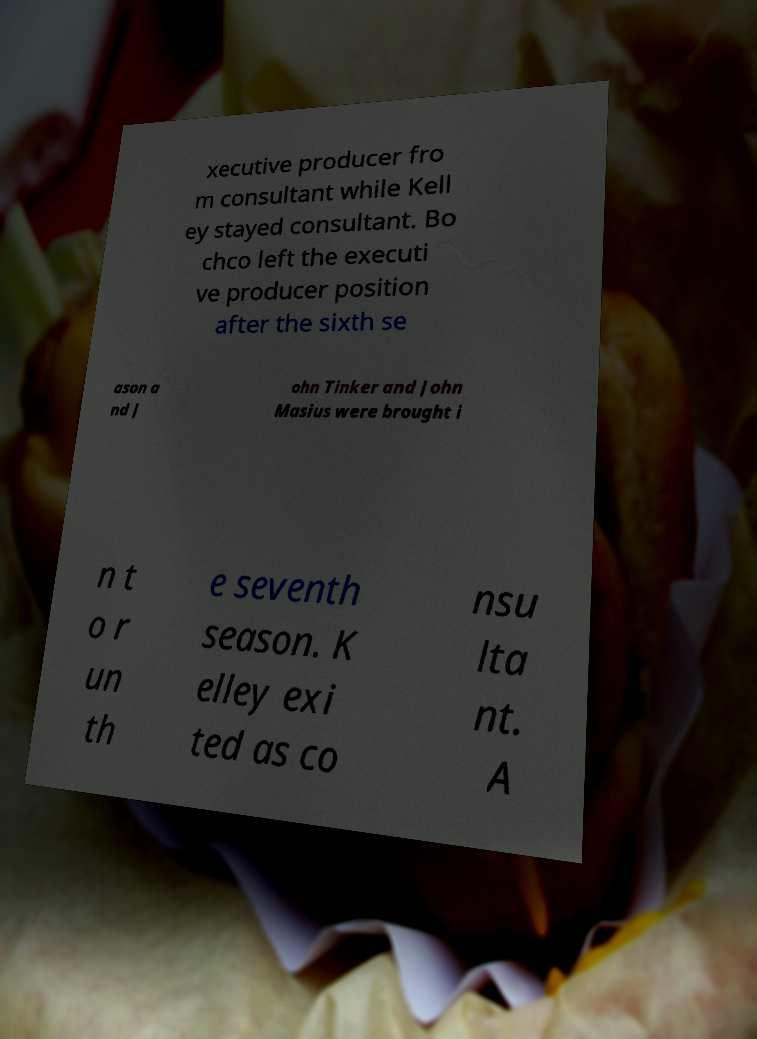Please read and relay the text visible in this image. What does it say? xecutive producer fro m consultant while Kell ey stayed consultant. Bo chco left the executi ve producer position after the sixth se ason a nd J ohn Tinker and John Masius were brought i n t o r un th e seventh season. K elley exi ted as co nsu lta nt. A 